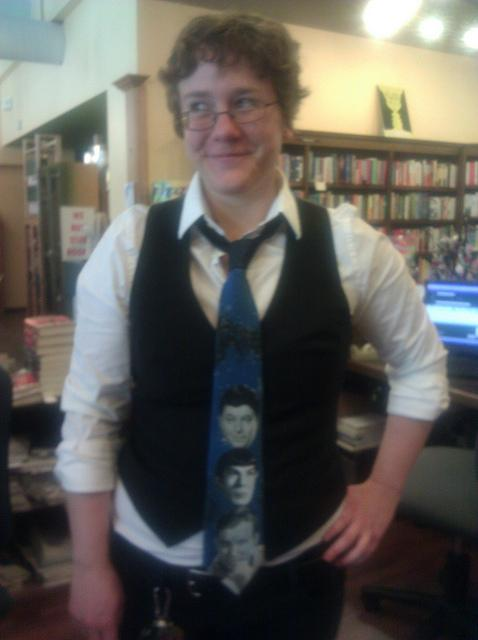What type of shop is the person wearing the tie in?

Choices:
A) deli
B) restaurant
C) grocery store
D) book store book store 